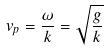Convert formula to latex. <formula><loc_0><loc_0><loc_500><loc_500>v _ { p } = \frac { \omega } { k } = \sqrt { \frac { g } { k } }</formula> 